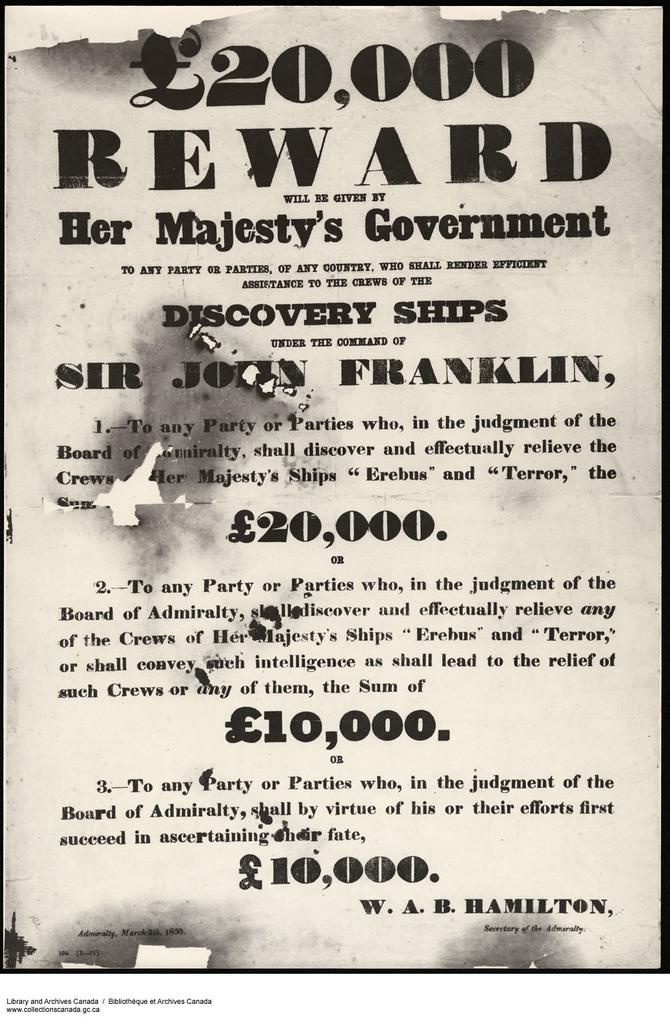Why are they rewarding that money for?
Offer a terse response. Discovery ships. How much is the top reward?
Keep it short and to the point. 20,000. 